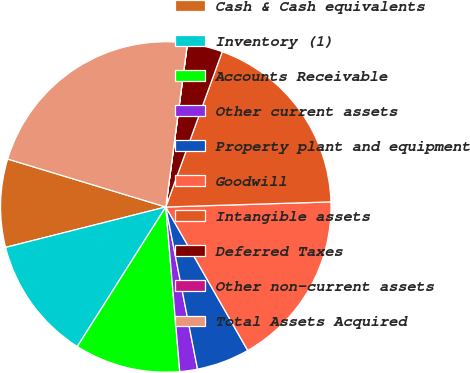<chart> <loc_0><loc_0><loc_500><loc_500><pie_chart><fcel>Cash & Cash equivalents<fcel>Inventory (1)<fcel>Accounts Receivable<fcel>Other current assets<fcel>Property plant and equipment<fcel>Goodwill<fcel>Intangible assets<fcel>Deferred Taxes<fcel>Other non-current assets<fcel>Total Assets Acquired<nl><fcel>8.62%<fcel>12.07%<fcel>10.34%<fcel>1.73%<fcel>5.18%<fcel>17.23%<fcel>18.96%<fcel>3.45%<fcel>0.01%<fcel>22.4%<nl></chart> 